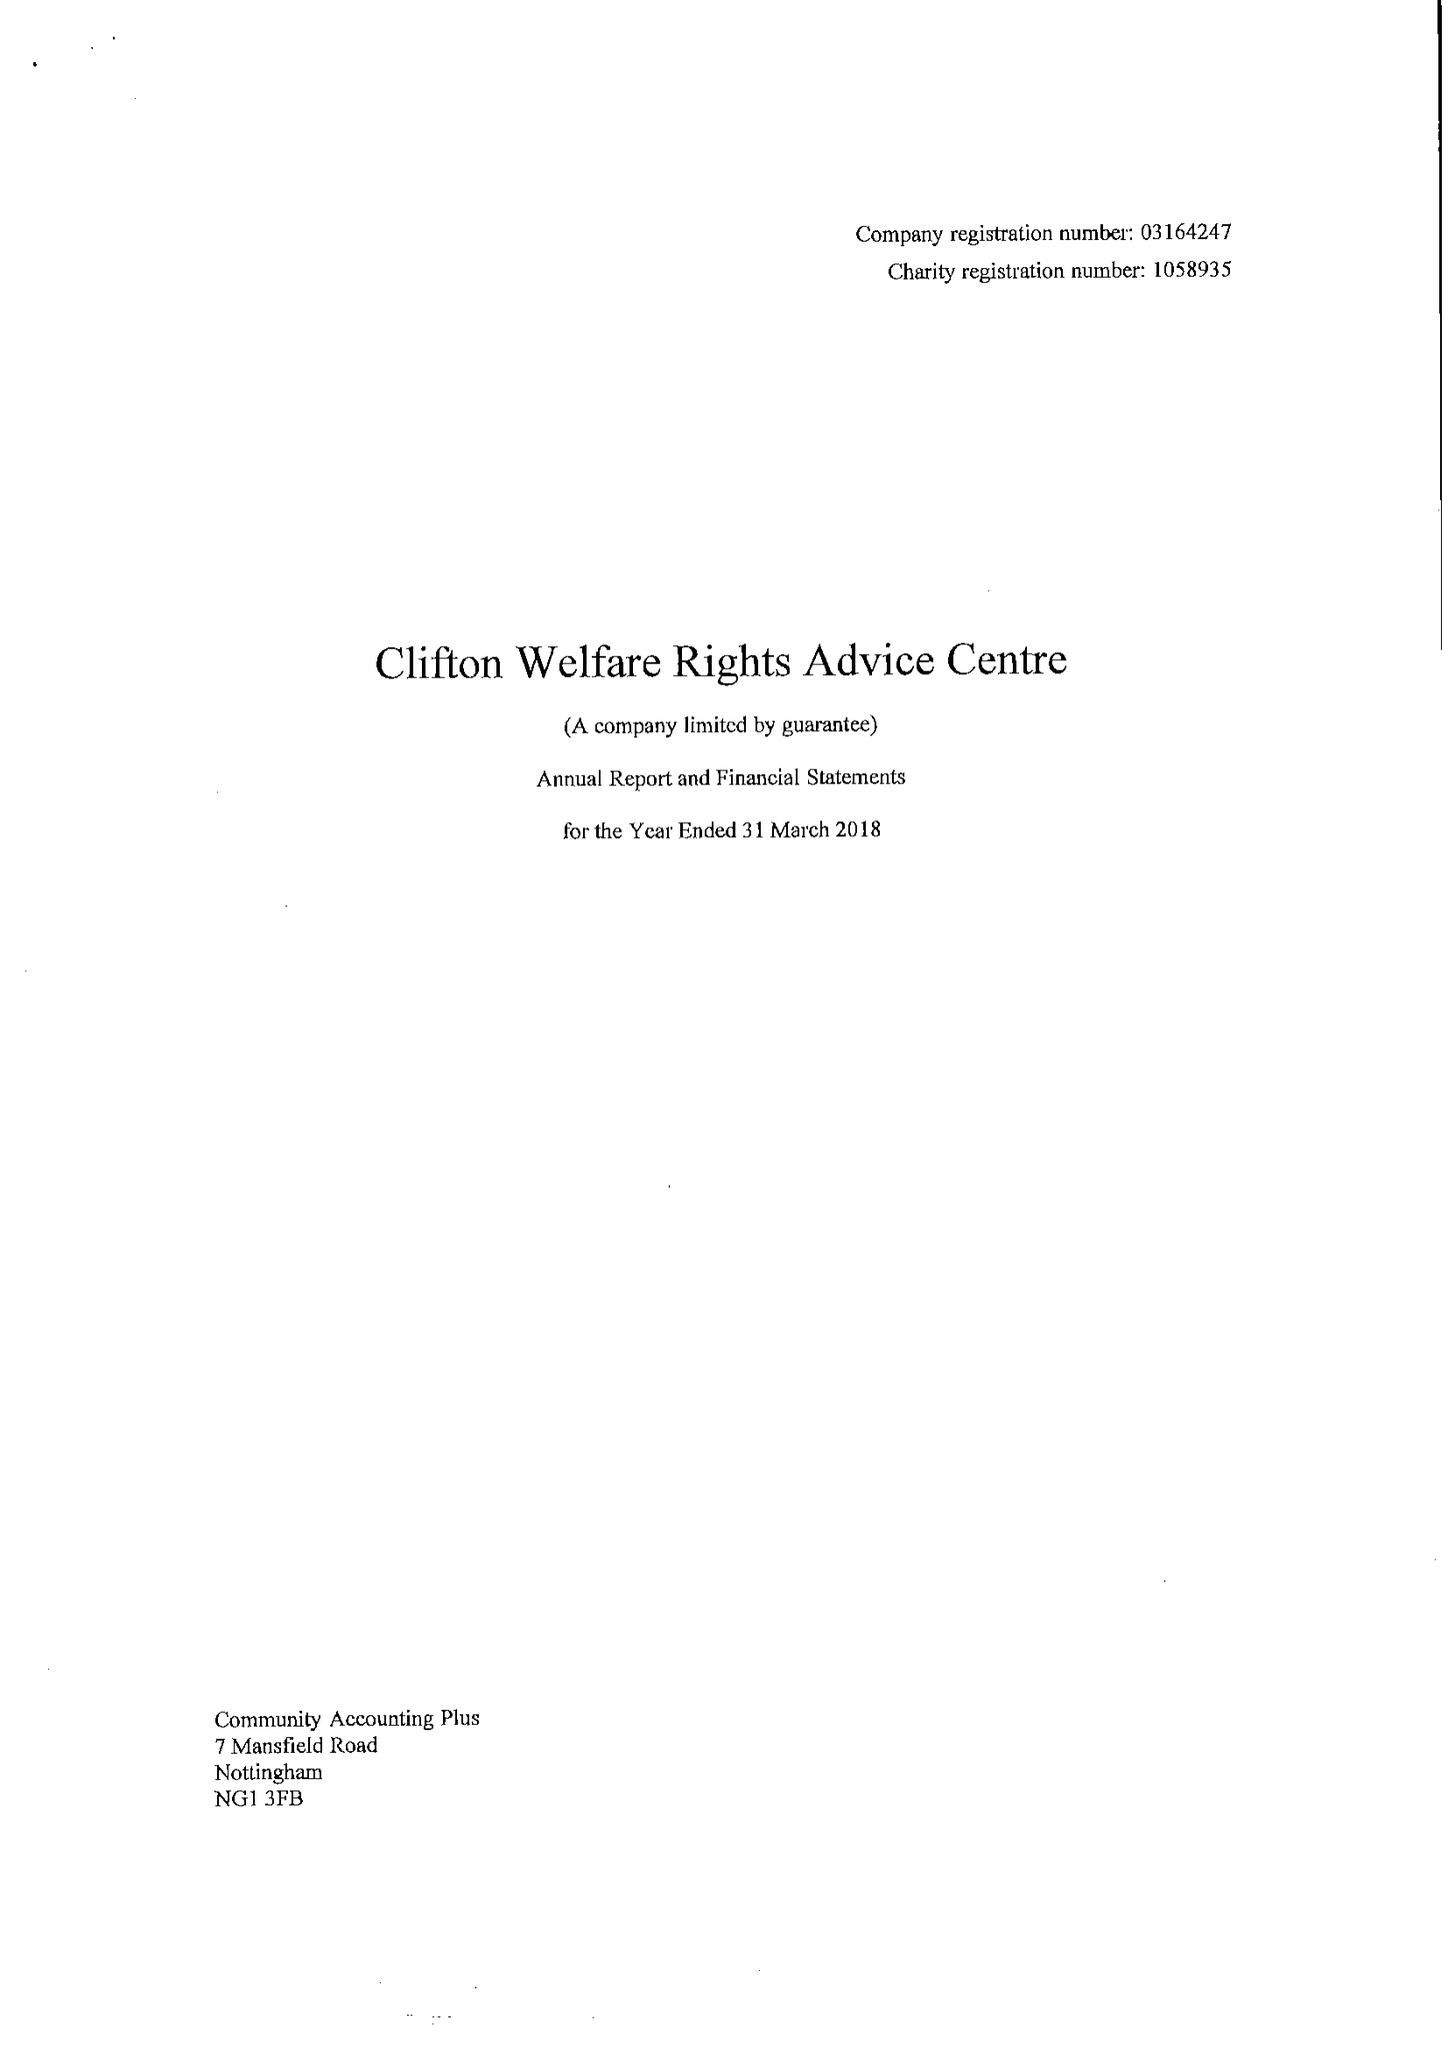What is the value for the address__post_town?
Answer the question using a single word or phrase. NOTTINGHAM 